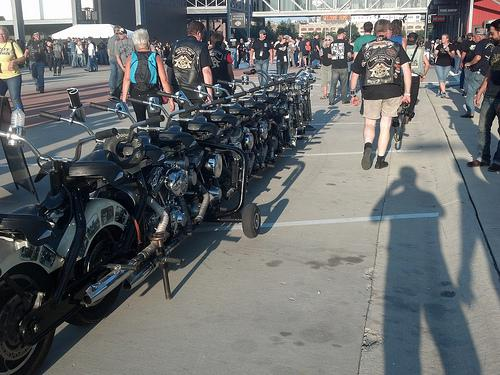Question: who is in the picture?
Choices:
A. Bicyclists.
B. Pedestrians.
C. Passengers.
D. Runners.
Answer with the letter. Answer: B Question: what color is the cement?
Choices:
A. Gray.
B. White.
C. Black.
D. Brown.
Answer with the letter. Answer: A Question: where was the picture taken?
Choices:
A. On a country road.
B. In the park.
C. In a store.
D. On a busy sidewalk.
Answer with the letter. Answer: D Question: what are the people doing?
Choices:
A. Walking.
B. Running.
C. Sitting.
D. Sleeping.
Answer with the letter. Answer: A 